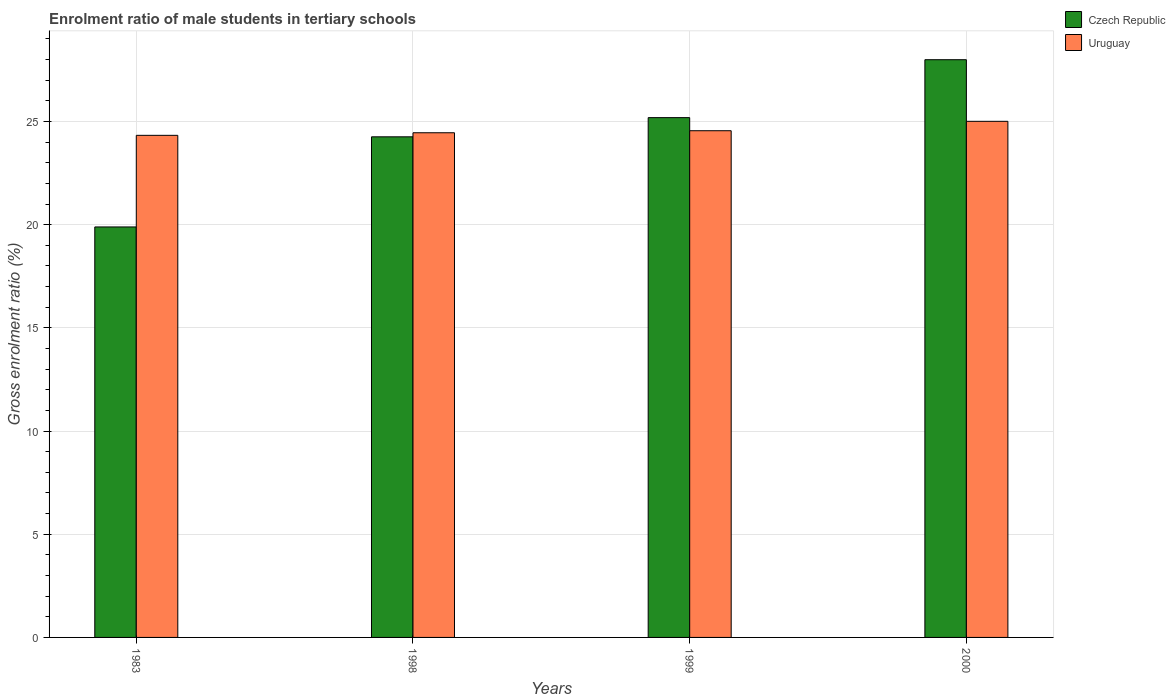How many different coloured bars are there?
Your response must be concise. 2. How many bars are there on the 3rd tick from the left?
Offer a very short reply. 2. In how many cases, is the number of bars for a given year not equal to the number of legend labels?
Offer a terse response. 0. What is the enrolment ratio of male students in tertiary schools in Uruguay in 1983?
Your response must be concise. 24.33. Across all years, what is the maximum enrolment ratio of male students in tertiary schools in Uruguay?
Offer a terse response. 25.01. Across all years, what is the minimum enrolment ratio of male students in tertiary schools in Czech Republic?
Give a very brief answer. 19.89. In which year was the enrolment ratio of male students in tertiary schools in Czech Republic maximum?
Give a very brief answer. 2000. In which year was the enrolment ratio of male students in tertiary schools in Uruguay minimum?
Your response must be concise. 1983. What is the total enrolment ratio of male students in tertiary schools in Uruguay in the graph?
Your answer should be compact. 98.35. What is the difference between the enrolment ratio of male students in tertiary schools in Czech Republic in 1998 and that in 2000?
Your answer should be very brief. -3.74. What is the difference between the enrolment ratio of male students in tertiary schools in Czech Republic in 1983 and the enrolment ratio of male students in tertiary schools in Uruguay in 1999?
Provide a short and direct response. -4.66. What is the average enrolment ratio of male students in tertiary schools in Czech Republic per year?
Provide a short and direct response. 24.33. In the year 1999, what is the difference between the enrolment ratio of male students in tertiary schools in Czech Republic and enrolment ratio of male students in tertiary schools in Uruguay?
Your response must be concise. 0.63. In how many years, is the enrolment ratio of male students in tertiary schools in Uruguay greater than 18 %?
Your response must be concise. 4. What is the ratio of the enrolment ratio of male students in tertiary schools in Uruguay in 1983 to that in 2000?
Provide a short and direct response. 0.97. What is the difference between the highest and the second highest enrolment ratio of male students in tertiary schools in Czech Republic?
Provide a succinct answer. 2.81. What is the difference between the highest and the lowest enrolment ratio of male students in tertiary schools in Uruguay?
Your answer should be very brief. 0.68. In how many years, is the enrolment ratio of male students in tertiary schools in Czech Republic greater than the average enrolment ratio of male students in tertiary schools in Czech Republic taken over all years?
Offer a terse response. 2. Is the sum of the enrolment ratio of male students in tertiary schools in Uruguay in 1999 and 2000 greater than the maximum enrolment ratio of male students in tertiary schools in Czech Republic across all years?
Provide a short and direct response. Yes. What does the 2nd bar from the left in 1983 represents?
Provide a succinct answer. Uruguay. What does the 1st bar from the right in 2000 represents?
Your answer should be compact. Uruguay. How many bars are there?
Make the answer very short. 8. How many years are there in the graph?
Your answer should be very brief. 4. Are the values on the major ticks of Y-axis written in scientific E-notation?
Offer a terse response. No. Does the graph contain any zero values?
Provide a short and direct response. No. Does the graph contain grids?
Offer a very short reply. Yes. Where does the legend appear in the graph?
Ensure brevity in your answer.  Top right. How are the legend labels stacked?
Your answer should be very brief. Vertical. What is the title of the graph?
Ensure brevity in your answer.  Enrolment ratio of male students in tertiary schools. What is the label or title of the Y-axis?
Offer a terse response. Gross enrolment ratio (%). What is the Gross enrolment ratio (%) in Czech Republic in 1983?
Provide a short and direct response. 19.89. What is the Gross enrolment ratio (%) of Uruguay in 1983?
Your response must be concise. 24.33. What is the Gross enrolment ratio (%) of Czech Republic in 1998?
Offer a very short reply. 24.26. What is the Gross enrolment ratio (%) in Uruguay in 1998?
Your answer should be very brief. 24.45. What is the Gross enrolment ratio (%) in Czech Republic in 1999?
Your answer should be very brief. 25.19. What is the Gross enrolment ratio (%) in Uruguay in 1999?
Ensure brevity in your answer.  24.55. What is the Gross enrolment ratio (%) in Czech Republic in 2000?
Make the answer very short. 27.99. What is the Gross enrolment ratio (%) of Uruguay in 2000?
Offer a very short reply. 25.01. Across all years, what is the maximum Gross enrolment ratio (%) in Czech Republic?
Provide a short and direct response. 27.99. Across all years, what is the maximum Gross enrolment ratio (%) of Uruguay?
Offer a terse response. 25.01. Across all years, what is the minimum Gross enrolment ratio (%) of Czech Republic?
Give a very brief answer. 19.89. Across all years, what is the minimum Gross enrolment ratio (%) of Uruguay?
Ensure brevity in your answer.  24.33. What is the total Gross enrolment ratio (%) in Czech Republic in the graph?
Provide a short and direct response. 97.33. What is the total Gross enrolment ratio (%) of Uruguay in the graph?
Give a very brief answer. 98.35. What is the difference between the Gross enrolment ratio (%) of Czech Republic in 1983 and that in 1998?
Provide a succinct answer. -4.37. What is the difference between the Gross enrolment ratio (%) in Uruguay in 1983 and that in 1998?
Offer a very short reply. -0.13. What is the difference between the Gross enrolment ratio (%) of Czech Republic in 1983 and that in 1999?
Make the answer very short. -5.3. What is the difference between the Gross enrolment ratio (%) of Uruguay in 1983 and that in 1999?
Give a very brief answer. -0.22. What is the difference between the Gross enrolment ratio (%) of Czech Republic in 1983 and that in 2000?
Your answer should be very brief. -8.1. What is the difference between the Gross enrolment ratio (%) of Uruguay in 1983 and that in 2000?
Your answer should be very brief. -0.68. What is the difference between the Gross enrolment ratio (%) of Czech Republic in 1998 and that in 1999?
Your answer should be very brief. -0.93. What is the difference between the Gross enrolment ratio (%) in Uruguay in 1998 and that in 1999?
Offer a terse response. -0.1. What is the difference between the Gross enrolment ratio (%) in Czech Republic in 1998 and that in 2000?
Ensure brevity in your answer.  -3.74. What is the difference between the Gross enrolment ratio (%) of Uruguay in 1998 and that in 2000?
Your answer should be very brief. -0.55. What is the difference between the Gross enrolment ratio (%) of Czech Republic in 1999 and that in 2000?
Ensure brevity in your answer.  -2.81. What is the difference between the Gross enrolment ratio (%) in Uruguay in 1999 and that in 2000?
Your answer should be very brief. -0.46. What is the difference between the Gross enrolment ratio (%) of Czech Republic in 1983 and the Gross enrolment ratio (%) of Uruguay in 1998?
Make the answer very short. -4.56. What is the difference between the Gross enrolment ratio (%) of Czech Republic in 1983 and the Gross enrolment ratio (%) of Uruguay in 1999?
Make the answer very short. -4.66. What is the difference between the Gross enrolment ratio (%) in Czech Republic in 1983 and the Gross enrolment ratio (%) in Uruguay in 2000?
Offer a terse response. -5.12. What is the difference between the Gross enrolment ratio (%) in Czech Republic in 1998 and the Gross enrolment ratio (%) in Uruguay in 1999?
Provide a succinct answer. -0.3. What is the difference between the Gross enrolment ratio (%) in Czech Republic in 1998 and the Gross enrolment ratio (%) in Uruguay in 2000?
Keep it short and to the point. -0.75. What is the difference between the Gross enrolment ratio (%) in Czech Republic in 1999 and the Gross enrolment ratio (%) in Uruguay in 2000?
Make the answer very short. 0.18. What is the average Gross enrolment ratio (%) in Czech Republic per year?
Provide a succinct answer. 24.33. What is the average Gross enrolment ratio (%) in Uruguay per year?
Make the answer very short. 24.59. In the year 1983, what is the difference between the Gross enrolment ratio (%) in Czech Republic and Gross enrolment ratio (%) in Uruguay?
Provide a short and direct response. -4.44. In the year 1998, what is the difference between the Gross enrolment ratio (%) in Czech Republic and Gross enrolment ratio (%) in Uruguay?
Your answer should be very brief. -0.2. In the year 1999, what is the difference between the Gross enrolment ratio (%) of Czech Republic and Gross enrolment ratio (%) of Uruguay?
Make the answer very short. 0.63. In the year 2000, what is the difference between the Gross enrolment ratio (%) in Czech Republic and Gross enrolment ratio (%) in Uruguay?
Your response must be concise. 2.99. What is the ratio of the Gross enrolment ratio (%) of Czech Republic in 1983 to that in 1998?
Your answer should be compact. 0.82. What is the ratio of the Gross enrolment ratio (%) of Uruguay in 1983 to that in 1998?
Offer a very short reply. 0.99. What is the ratio of the Gross enrolment ratio (%) of Czech Republic in 1983 to that in 1999?
Your answer should be compact. 0.79. What is the ratio of the Gross enrolment ratio (%) of Uruguay in 1983 to that in 1999?
Make the answer very short. 0.99. What is the ratio of the Gross enrolment ratio (%) in Czech Republic in 1983 to that in 2000?
Give a very brief answer. 0.71. What is the ratio of the Gross enrolment ratio (%) of Uruguay in 1983 to that in 2000?
Make the answer very short. 0.97. What is the ratio of the Gross enrolment ratio (%) of Czech Republic in 1998 to that in 1999?
Your answer should be compact. 0.96. What is the ratio of the Gross enrolment ratio (%) of Czech Republic in 1998 to that in 2000?
Offer a very short reply. 0.87. What is the ratio of the Gross enrolment ratio (%) of Uruguay in 1998 to that in 2000?
Provide a short and direct response. 0.98. What is the ratio of the Gross enrolment ratio (%) of Czech Republic in 1999 to that in 2000?
Provide a succinct answer. 0.9. What is the ratio of the Gross enrolment ratio (%) of Uruguay in 1999 to that in 2000?
Provide a short and direct response. 0.98. What is the difference between the highest and the second highest Gross enrolment ratio (%) of Czech Republic?
Your answer should be very brief. 2.81. What is the difference between the highest and the second highest Gross enrolment ratio (%) of Uruguay?
Offer a terse response. 0.46. What is the difference between the highest and the lowest Gross enrolment ratio (%) in Czech Republic?
Provide a short and direct response. 8.1. What is the difference between the highest and the lowest Gross enrolment ratio (%) of Uruguay?
Ensure brevity in your answer.  0.68. 